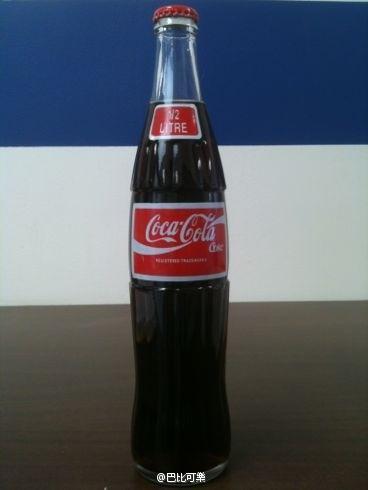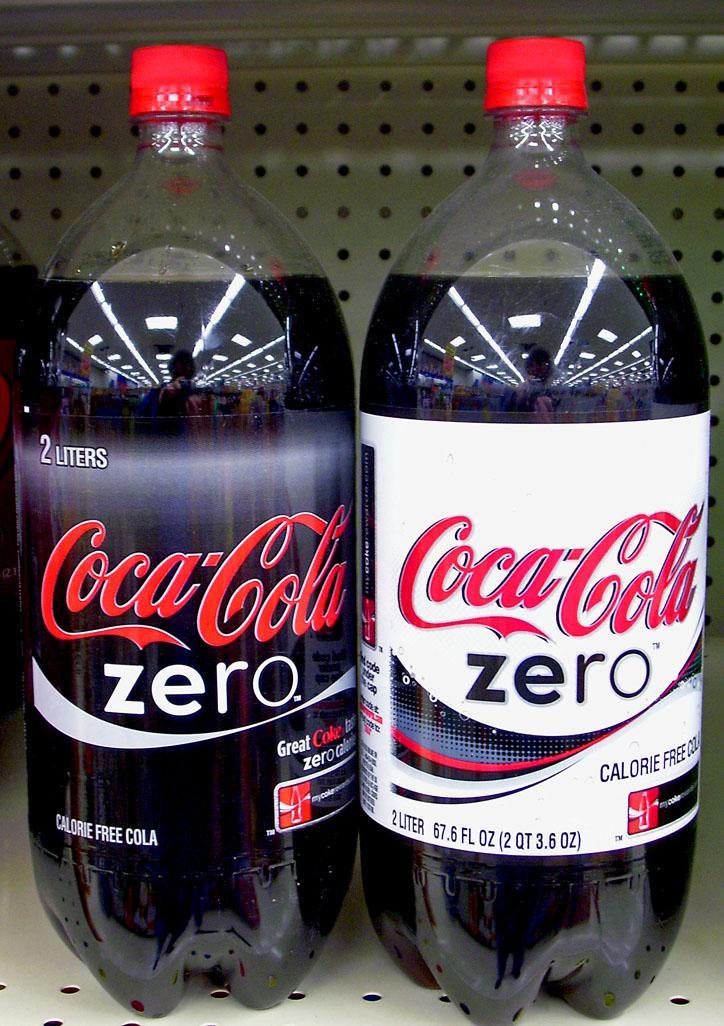The first image is the image on the left, the second image is the image on the right. For the images shown, is this caption "The left image includes three varieties of one brand of soda in transparent plastic bottles, which are in a row but not touching." true? Answer yes or no. No. The first image is the image on the left, the second image is the image on the right. Analyze the images presented: Is the assertion "The right image contains at least three bottles." valid? Answer yes or no. No. 